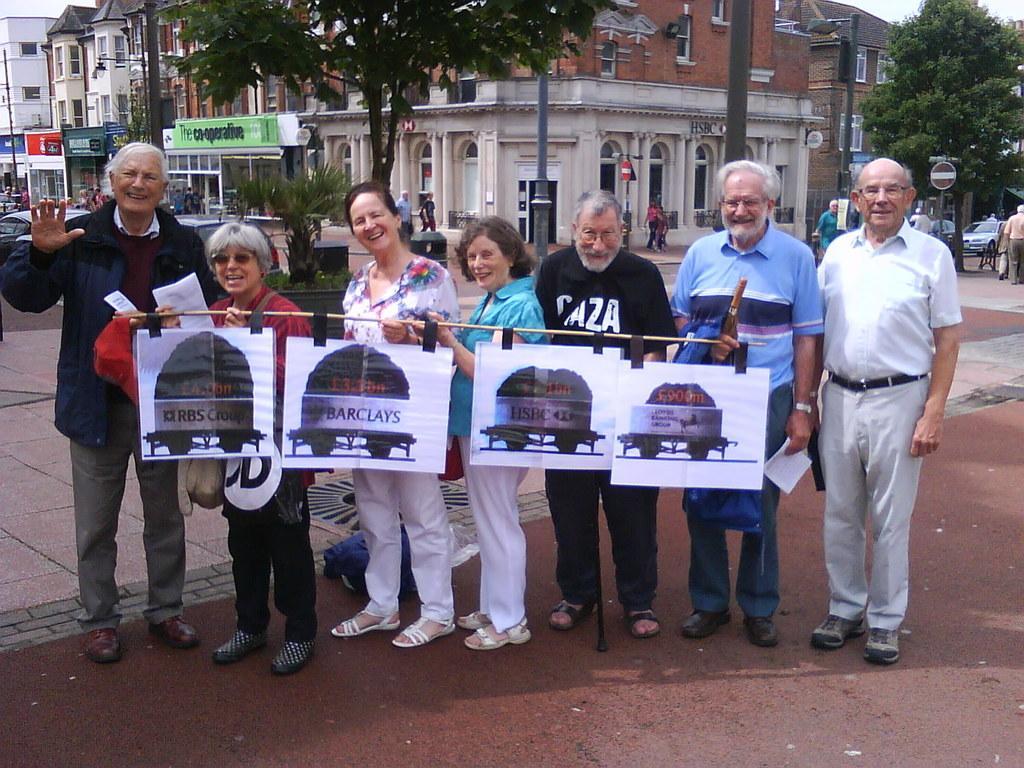Please provide a concise description of this image. In this image there are group of people who are standing on the floor and holding the wooden stick to which there are four posters. In the background there are buildings and trees. On the left side there is a road on which there are cars. On the right side there are few people who are walking on the road. 